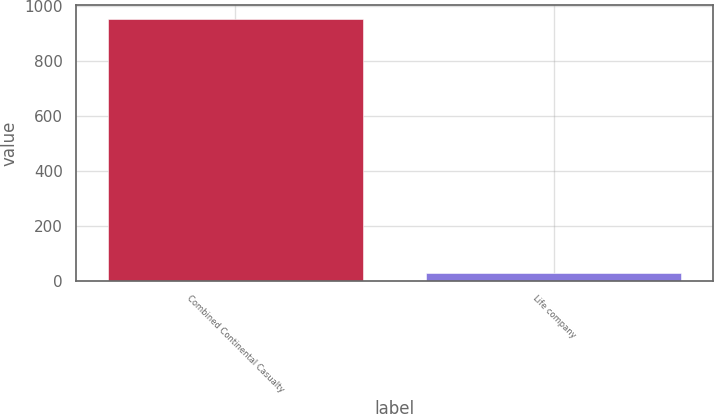<chart> <loc_0><loc_0><loc_500><loc_500><bar_chart><fcel>Combined Continental Casualty<fcel>Life company<nl><fcel>954<fcel>29<nl></chart> 